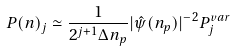Convert formula to latex. <formula><loc_0><loc_0><loc_500><loc_500>P ( n ) _ { j } \simeq \frac { 1 } { 2 ^ { j + 1 } \Delta n _ { p } } | \hat { \psi } ( n _ { p } ) | ^ { - 2 } P ^ { v a r } _ { j }</formula> 